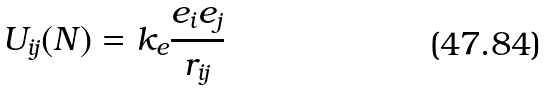Convert formula to latex. <formula><loc_0><loc_0><loc_500><loc_500>U _ { i j } ( N ) = k _ { e } \frac { e _ { i } e _ { j } } { r _ { i j } }</formula> 